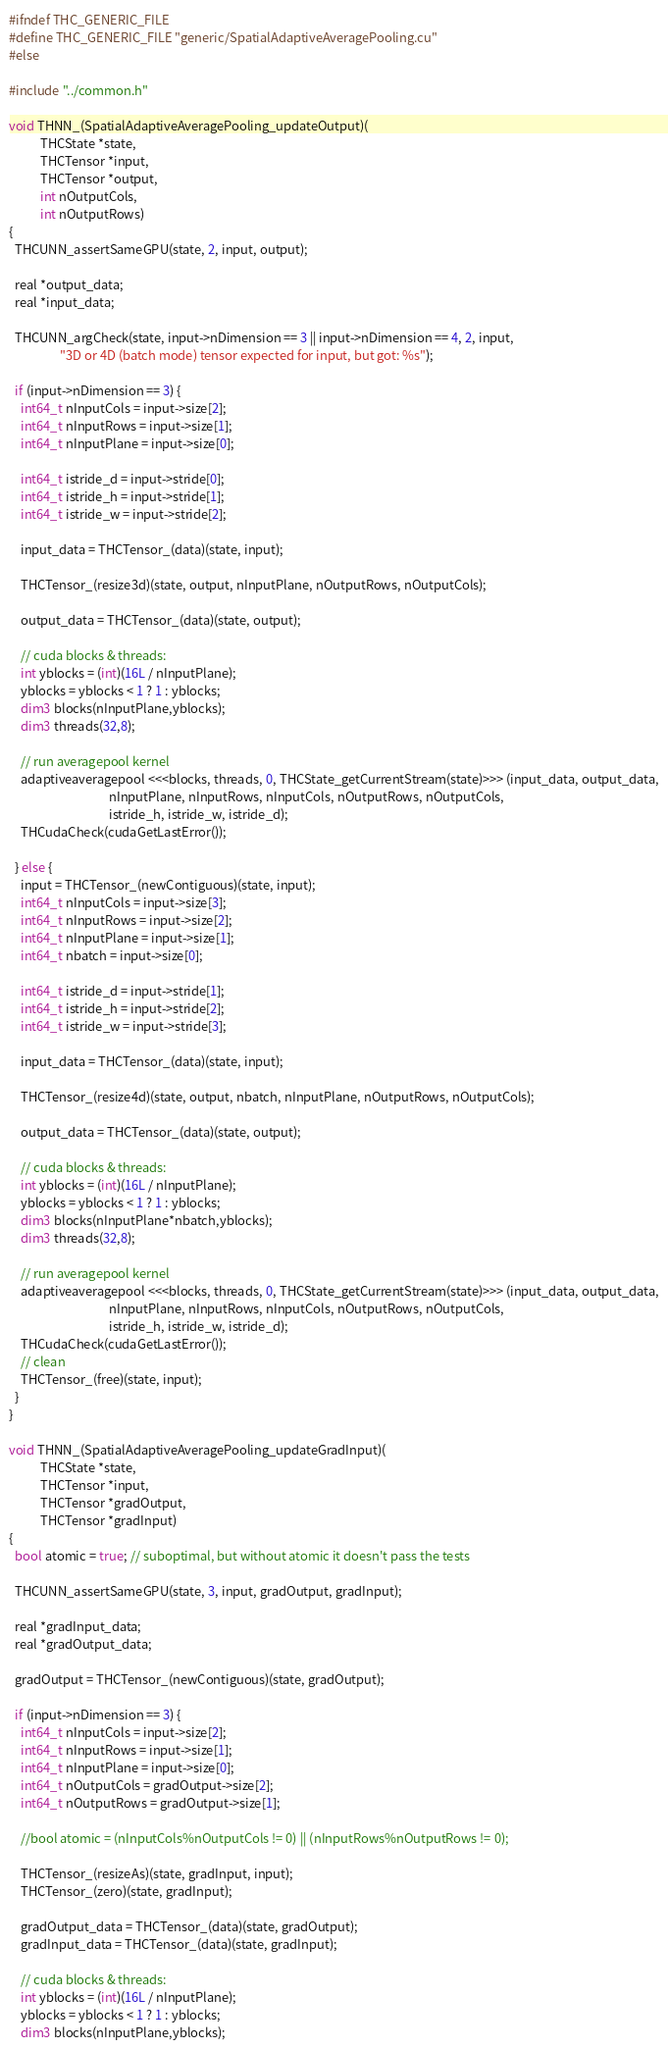Convert code to text. <code><loc_0><loc_0><loc_500><loc_500><_Cuda_>#ifndef THC_GENERIC_FILE
#define THC_GENERIC_FILE "generic/SpatialAdaptiveAveragePooling.cu"
#else

#include "../common.h"

void THNN_(SpatialAdaptiveAveragePooling_updateOutput)(
           THCState *state,
           THCTensor *input,
           THCTensor *output,
           int nOutputCols,
           int nOutputRows)
{
  THCUNN_assertSameGPU(state, 2, input, output);

  real *output_data;
  real *input_data;

  THCUNN_argCheck(state, input->nDimension == 3 || input->nDimension == 4, 2, input,
                  "3D or 4D (batch mode) tensor expected for input, but got: %s");

  if (input->nDimension == 3) {
    int64_t nInputCols = input->size[2];
    int64_t nInputRows = input->size[1];
    int64_t nInputPlane = input->size[0];

    int64_t istride_d = input->stride[0];
    int64_t istride_h = input->stride[1];
    int64_t istride_w = input->stride[2];

    input_data = THCTensor_(data)(state, input);

    THCTensor_(resize3d)(state, output, nInputPlane, nOutputRows, nOutputCols);

    output_data = THCTensor_(data)(state, output);

    // cuda blocks & threads:
    int yblocks = (int)(16L / nInputPlane);
    yblocks = yblocks < 1 ? 1 : yblocks;
    dim3 blocks(nInputPlane,yblocks);
    dim3 threads(32,8);

    // run averagepool kernel
    adaptiveaveragepool <<<blocks, threads, 0, THCState_getCurrentStream(state)>>> (input_data, output_data,
                                   nInputPlane, nInputRows, nInputCols, nOutputRows, nOutputCols,
                                   istride_h, istride_w, istride_d);
    THCudaCheck(cudaGetLastError());

  } else {
    input = THCTensor_(newContiguous)(state, input);
    int64_t nInputCols = input->size[3];
    int64_t nInputRows = input->size[2];
    int64_t nInputPlane = input->size[1];
    int64_t nbatch = input->size[0];

    int64_t istride_d = input->stride[1];
    int64_t istride_h = input->stride[2];
    int64_t istride_w = input->stride[3];

    input_data = THCTensor_(data)(state, input);

    THCTensor_(resize4d)(state, output, nbatch, nInputPlane, nOutputRows, nOutputCols);

    output_data = THCTensor_(data)(state, output);

    // cuda blocks & threads:
    int yblocks = (int)(16L / nInputPlane);
    yblocks = yblocks < 1 ? 1 : yblocks;
    dim3 blocks(nInputPlane*nbatch,yblocks);
    dim3 threads(32,8);

    // run averagepool kernel
    adaptiveaveragepool <<<blocks, threads, 0, THCState_getCurrentStream(state)>>> (input_data, output_data,
                                   nInputPlane, nInputRows, nInputCols, nOutputRows, nOutputCols,
                                   istride_h, istride_w, istride_d);
    THCudaCheck(cudaGetLastError());
    // clean
    THCTensor_(free)(state, input);
  }
}

void THNN_(SpatialAdaptiveAveragePooling_updateGradInput)(
           THCState *state,
           THCTensor *input,
           THCTensor *gradOutput,
           THCTensor *gradInput)
{
  bool atomic = true; // suboptimal, but without atomic it doesn't pass the tests

  THCUNN_assertSameGPU(state, 3, input, gradOutput, gradInput);

  real *gradInput_data;
  real *gradOutput_data;

  gradOutput = THCTensor_(newContiguous)(state, gradOutput);

  if (input->nDimension == 3) {
    int64_t nInputCols = input->size[2];
    int64_t nInputRows = input->size[1];
    int64_t nInputPlane = input->size[0];
    int64_t nOutputCols = gradOutput->size[2];
    int64_t nOutputRows = gradOutput->size[1];

    //bool atomic = (nInputCols%nOutputCols != 0) || (nInputRows%nOutputRows != 0);

    THCTensor_(resizeAs)(state, gradInput, input);
    THCTensor_(zero)(state, gradInput);

    gradOutput_data = THCTensor_(data)(state, gradOutput);
    gradInput_data = THCTensor_(data)(state, gradInput);

    // cuda blocks & threads:
    int yblocks = (int)(16L / nInputPlane);
    yblocks = yblocks < 1 ? 1 : yblocks;
    dim3 blocks(nInputPlane,yblocks);</code> 